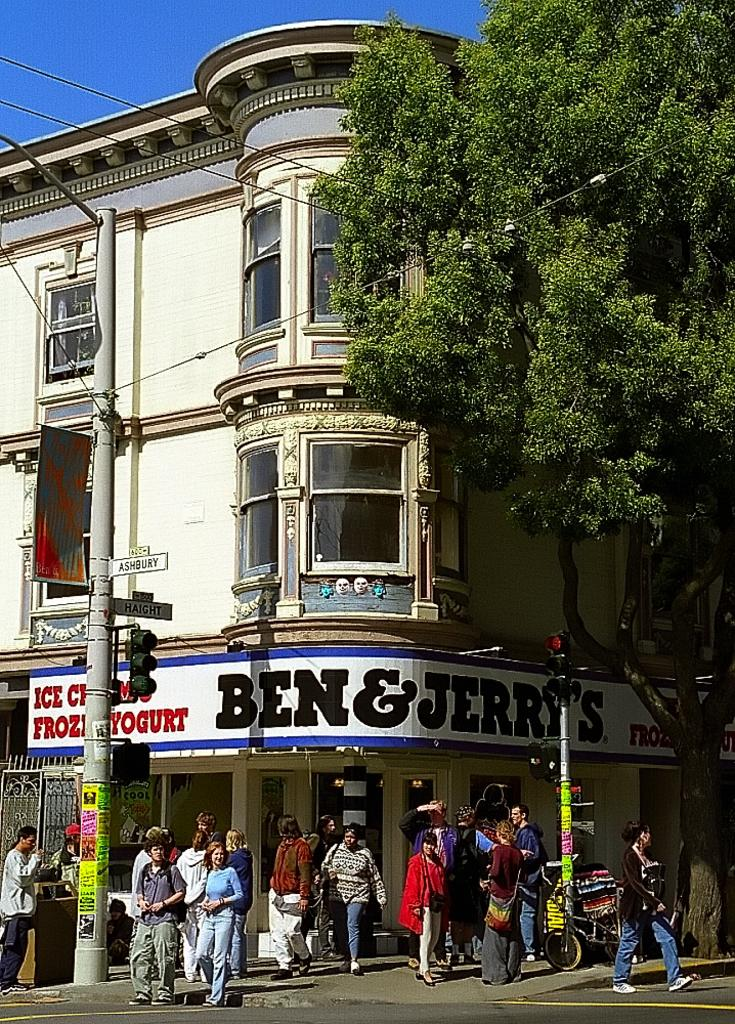<image>
Share a concise interpretation of the image provided. a ben and jerry's ice cream place with many people around 